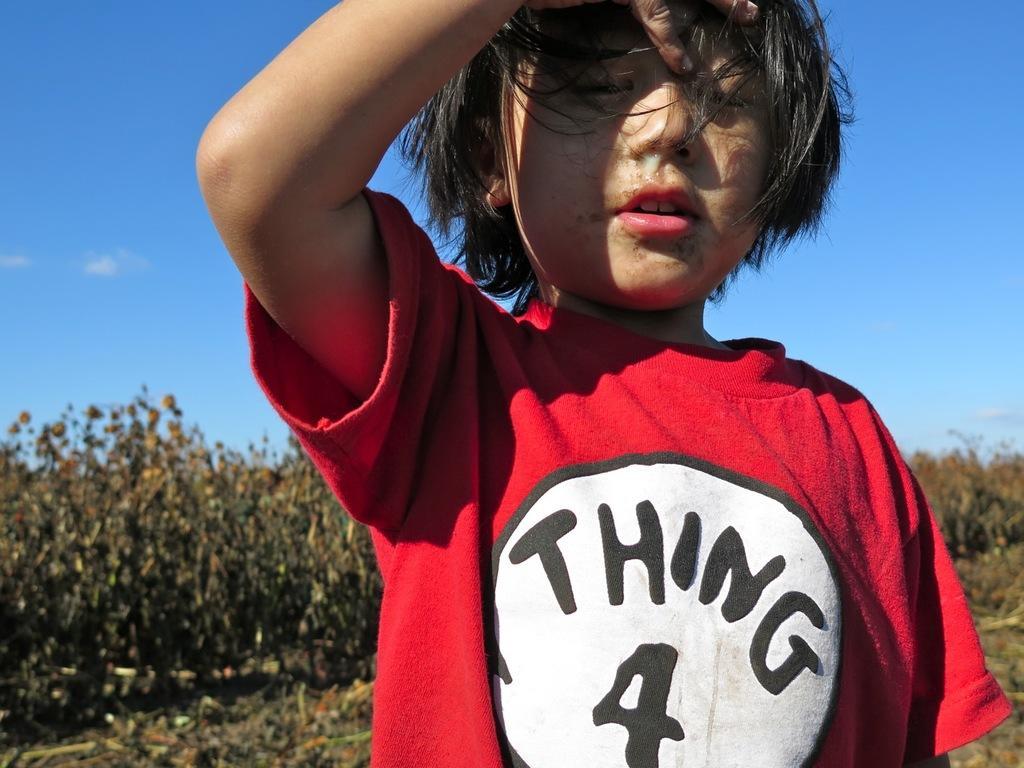How would you summarize this image in a sentence or two? In the picture we can see a child standing and keeping a hand to the head, the child is wearing a red T-shirt and some part white on it and in the background we can see some plants, grass and sky. 